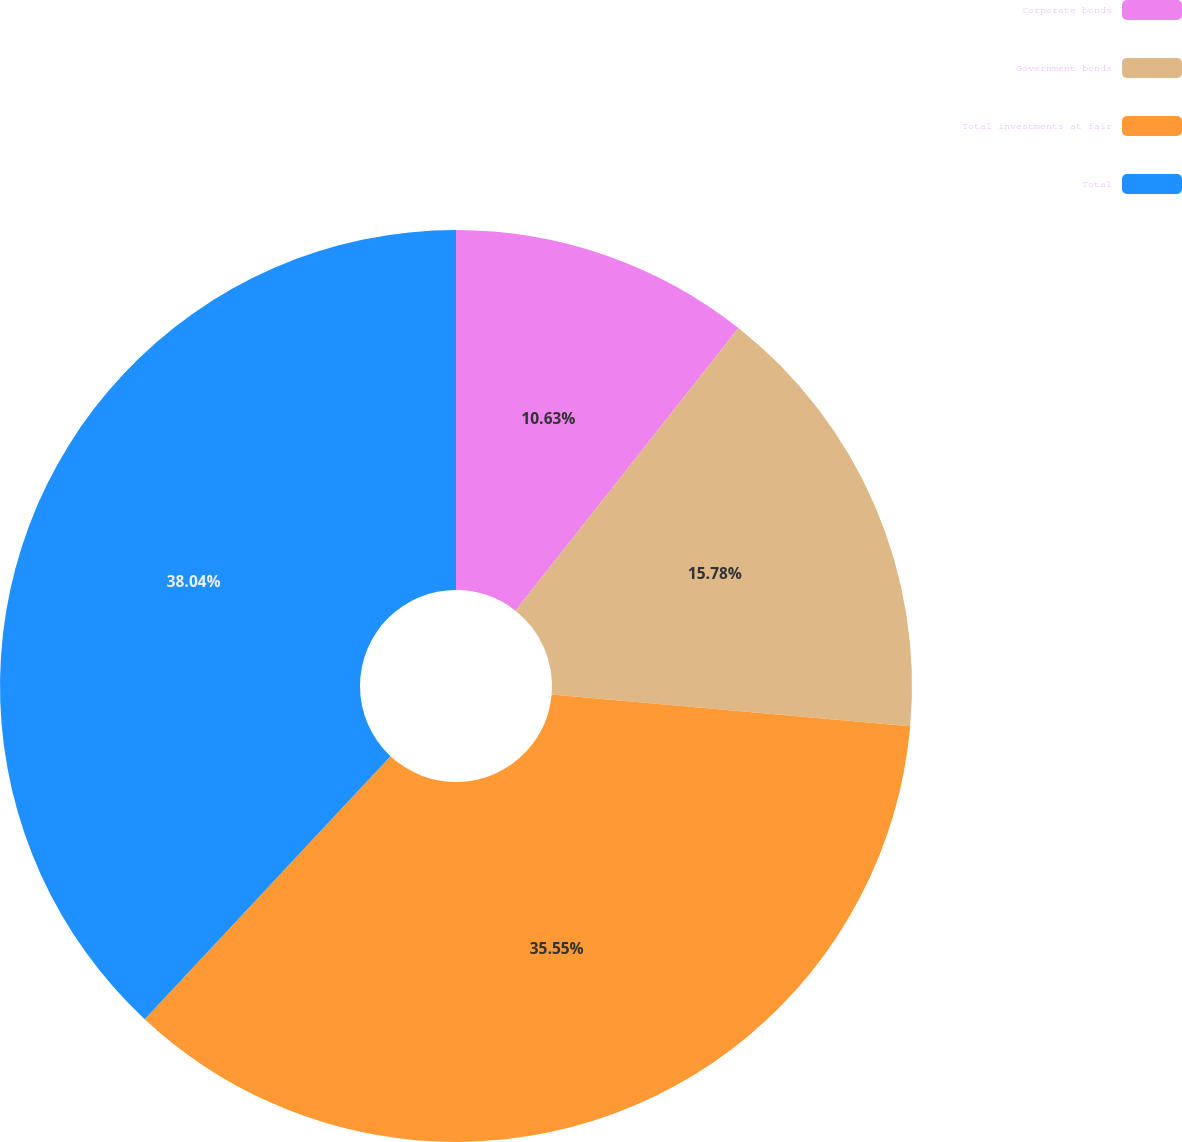Convert chart to OTSL. <chart><loc_0><loc_0><loc_500><loc_500><pie_chart><fcel>Corporate bonds<fcel>Government bonds<fcel>Total investments at fair<fcel>Total<nl><fcel>10.63%<fcel>15.78%<fcel>35.55%<fcel>38.04%<nl></chart> 